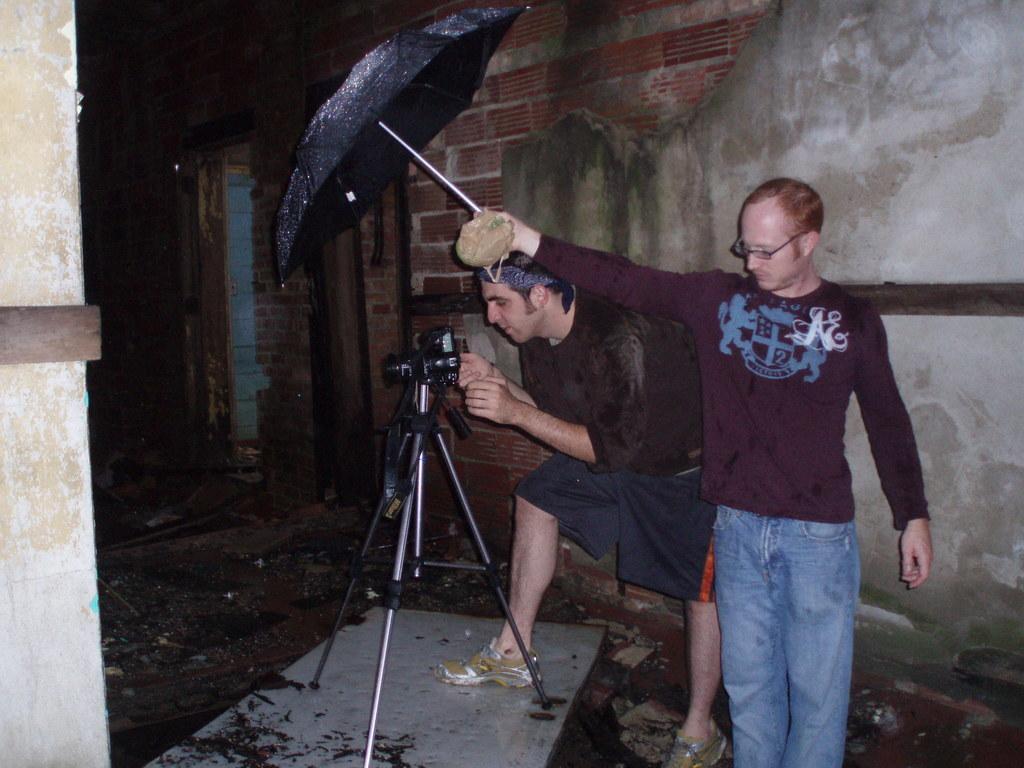Can you describe this image briefly? The man in brown T-shirt who is wearing spectacles is holding an umbrella in his hand. Beside him, the man in black T-shirt is holding the camera and he is clicking photos on the camera, which is placed on the camera hand. Behind them, we see the building. On the left side, we see a wall in white color. This picture is clicked in the dark. 